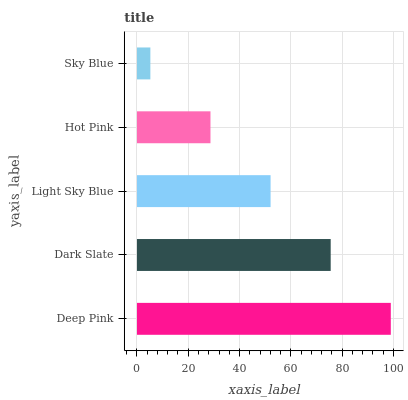Is Sky Blue the minimum?
Answer yes or no. Yes. Is Deep Pink the maximum?
Answer yes or no. Yes. Is Dark Slate the minimum?
Answer yes or no. No. Is Dark Slate the maximum?
Answer yes or no. No. Is Deep Pink greater than Dark Slate?
Answer yes or no. Yes. Is Dark Slate less than Deep Pink?
Answer yes or no. Yes. Is Dark Slate greater than Deep Pink?
Answer yes or no. No. Is Deep Pink less than Dark Slate?
Answer yes or no. No. Is Light Sky Blue the high median?
Answer yes or no. Yes. Is Light Sky Blue the low median?
Answer yes or no. Yes. Is Hot Pink the high median?
Answer yes or no. No. Is Sky Blue the low median?
Answer yes or no. No. 